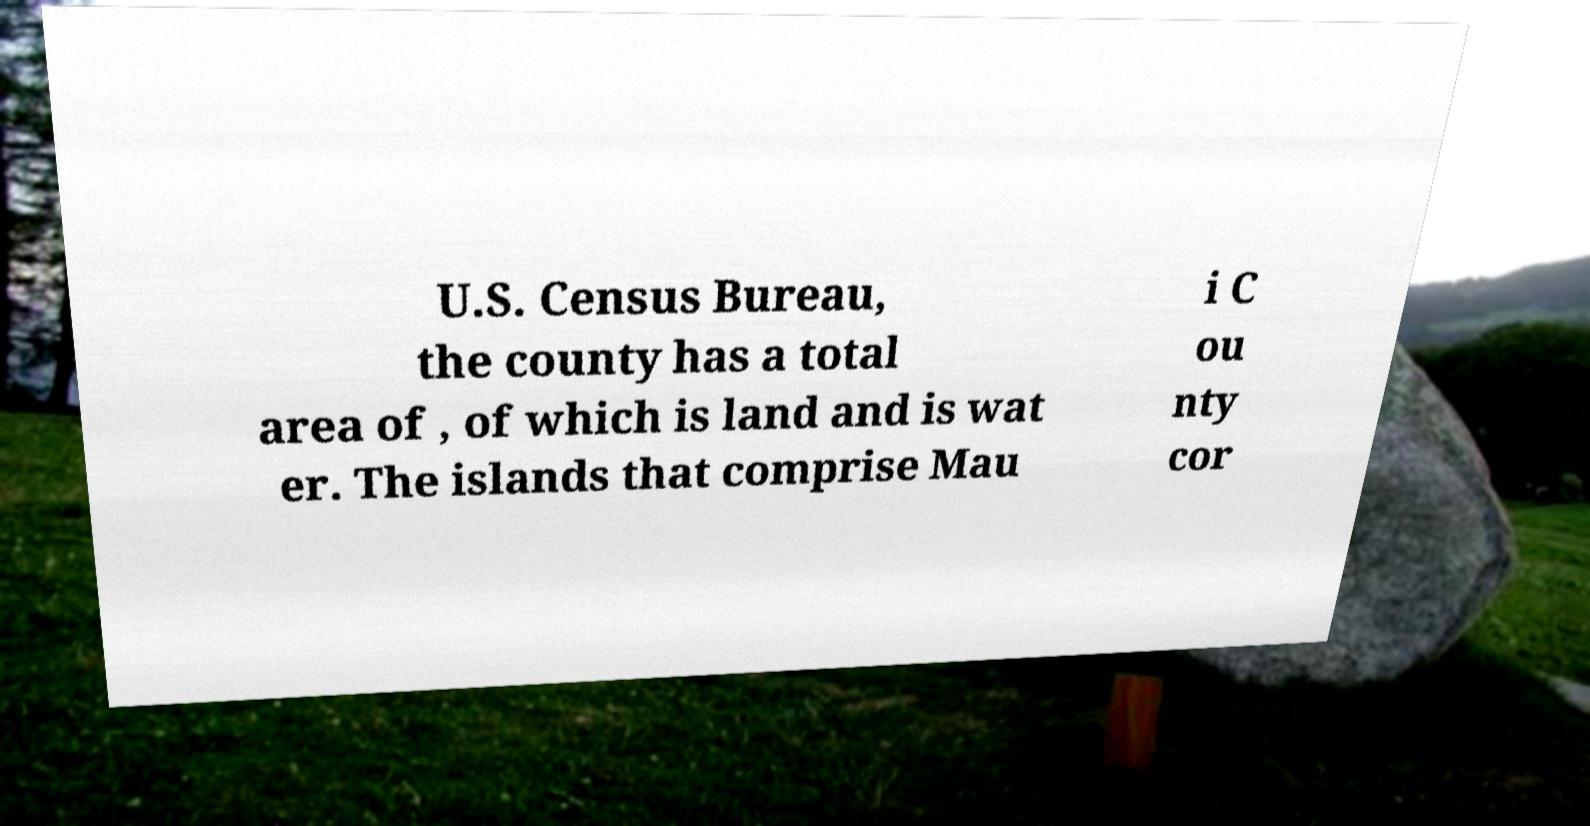For documentation purposes, I need the text within this image transcribed. Could you provide that? U.S. Census Bureau, the county has a total area of , of which is land and is wat er. The islands that comprise Mau i C ou nty cor 